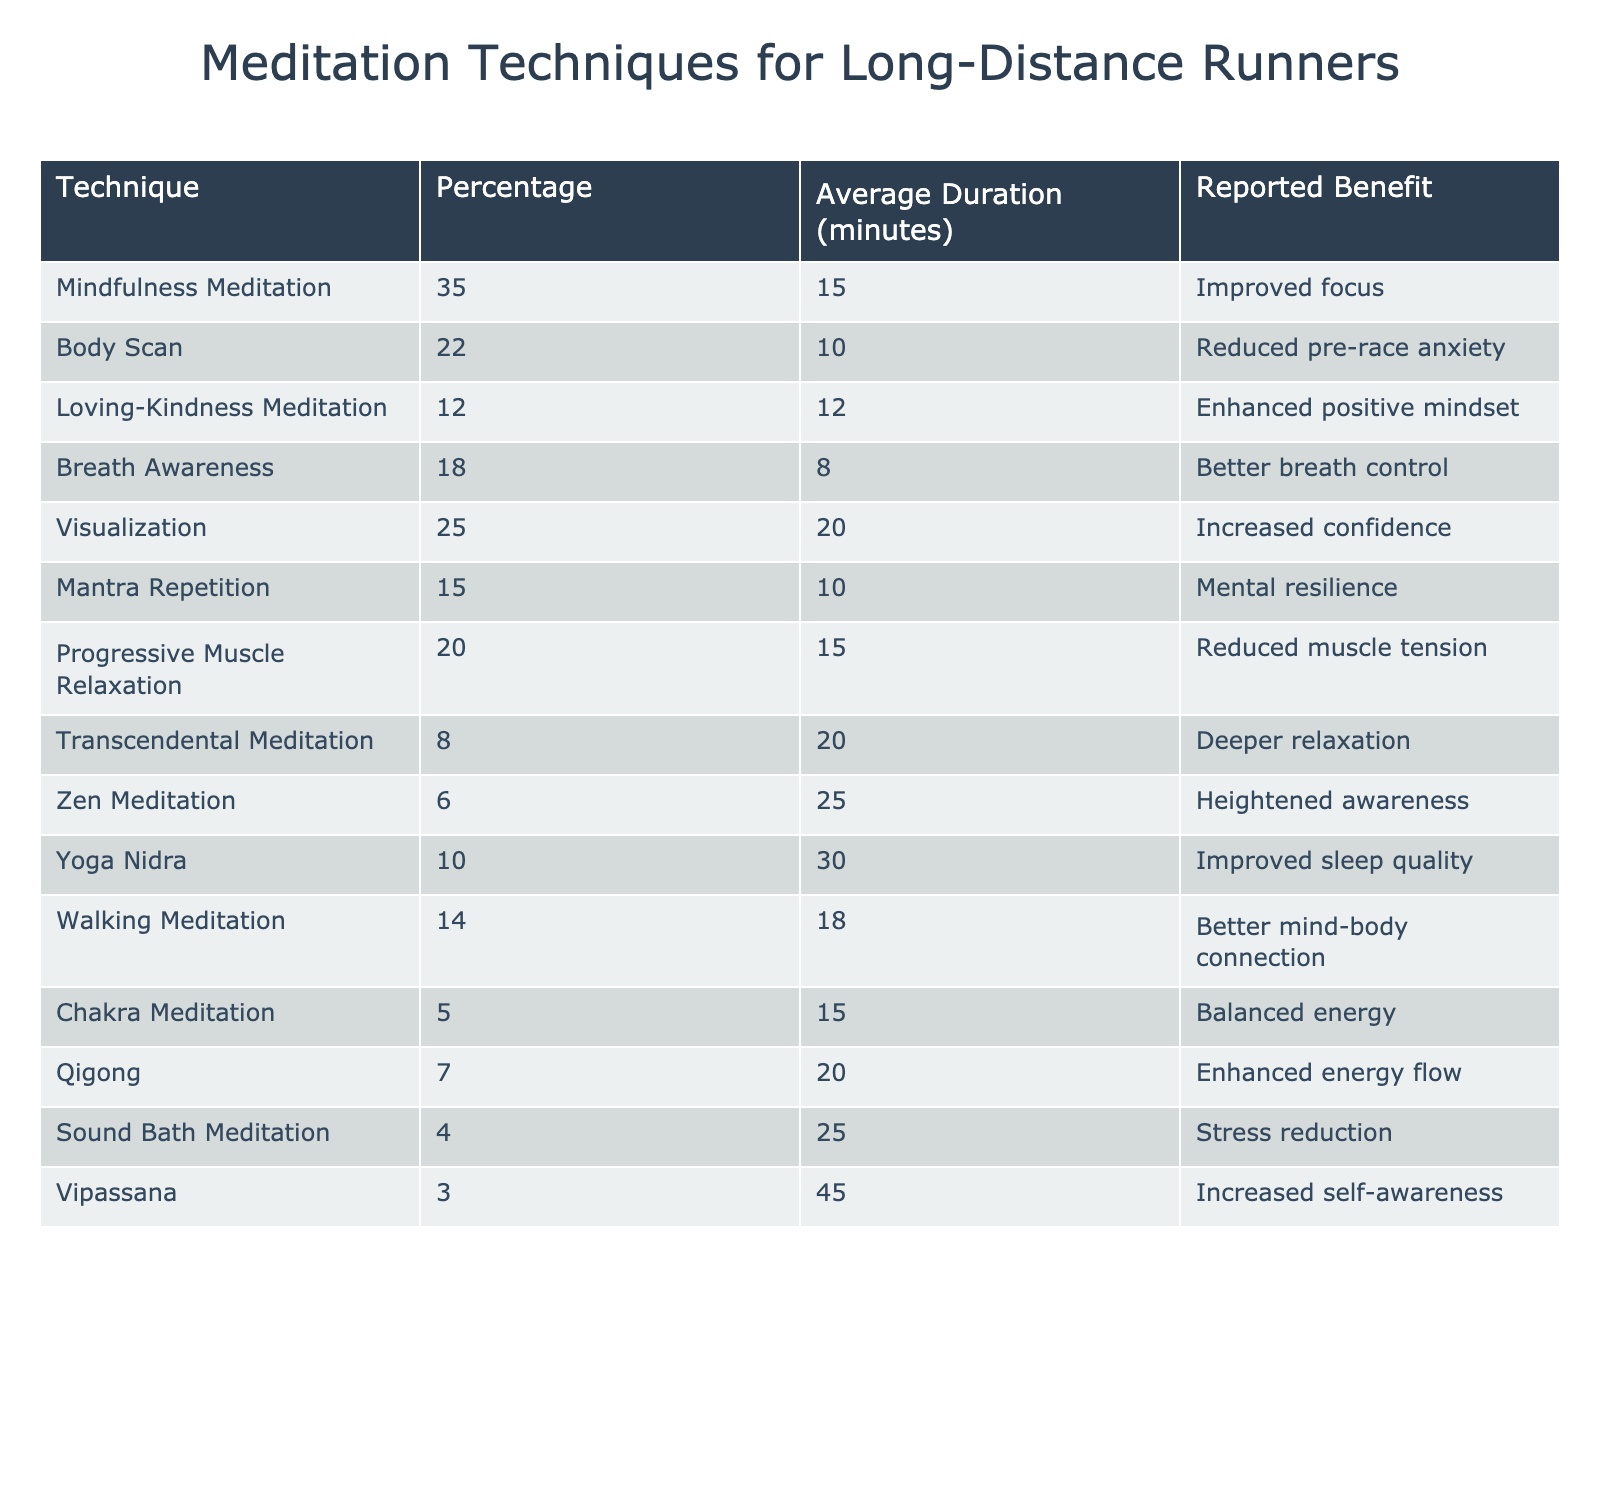What meditation technique is used by the highest percentage of long-distance runners? The highest percentage in the table is 35%, corresponding to Mindfulness Meditation.
Answer: Mindfulness Meditation What is the average duration of practice for Visualization? The table shows that Visualization has an average duration of 20 minutes.
Answer: 20 minutes How many techniques have an average duration of 15 minutes or more? The techniques with 15 minutes or more average duration are Mindfulness Meditation, Visualization, Progressive Muscle Relaxation, Yoga Nidra, and Zen Meditation. That's a total of 5 techniques.
Answer: 5 techniques What is the reported benefit of Body Scan meditation? According to the table, the reported benefit of Body Scan meditation is "Reduced pre-race anxiety."
Answer: Reduced pre-race anxiety Is the percentage of runners using Breath Awareness meditation greater than 15%? Breath Awareness is used by 18% of runners, which is greater than 15%.
Answer: Yes What is the total percentage of runners using Loving-Kindness and Qigong meditation combined? Adding the percentages, Loving-Kindness is 12% and Qigong is 7%; 12 + 7 = 19%.
Answer: 19% Which technique has the lowest average duration, and what is that duration? The lowest average duration is 8 minutes for Breath Awareness meditation.
Answer: 8 minutes How many techniques focus on enhancing positive mental states? The techniques that enhance positive mental states are Loving-Kindness Meditation, Visualization, and Mantra Repetition, totaling 3 techniques.
Answer: 3 techniques Is there any meditation technique that has a reported benefit of "Stress reduction" and a duration of more than 20 minutes? Yes, Sound Bath Meditation has a duration of 25 minutes and a reported benefit of stress reduction.
Answer: Yes What is the difference in percentage between the techniques with the highest and lowest reported percentage of use? The highest percentage is 35% for Mindfulness Meditation and the lowest is 3% for Vipassana. The difference is 35 - 3 = 32%.
Answer: 32% 